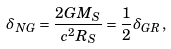Convert formula to latex. <formula><loc_0><loc_0><loc_500><loc_500>\delta _ { N G } = \frac { 2 G M _ { S } } { c ^ { 2 } R _ { S } } = \frac { 1 } { 2 } \delta _ { G R } ,</formula> 